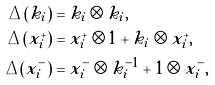<formula> <loc_0><loc_0><loc_500><loc_500>\Delta ( k _ { i } ) & = k _ { i } \otimes k _ { i } , \\ \Delta ( x ^ { + } _ { i } ) & = x ^ { + } _ { i } \otimes 1 + k _ { i } \otimes x ^ { + } _ { i } , \\ \Delta ( x ^ { - } _ { i } ) & = x ^ { - } _ { i } \otimes k _ { i } ^ { - 1 } + 1 \otimes x ^ { - } _ { i } ,</formula> 